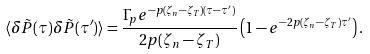Convert formula to latex. <formula><loc_0><loc_0><loc_500><loc_500>\langle \delta \tilde { P } ( \tau ) \delta \tilde { P } ( \tau ^ { \prime } ) \rangle = \frac { \Gamma _ { p } e ^ { - p ( \zeta _ { n } - \zeta _ { T } ) ( \tau - \tau ^ { \prime } ) } } { 2 p ( \zeta _ { n } - \zeta _ { T } ) } \left ( 1 - e ^ { - 2 p ( \zeta _ { n } - \zeta _ { T } ) \tau ^ { \prime } } \right ) .</formula> 